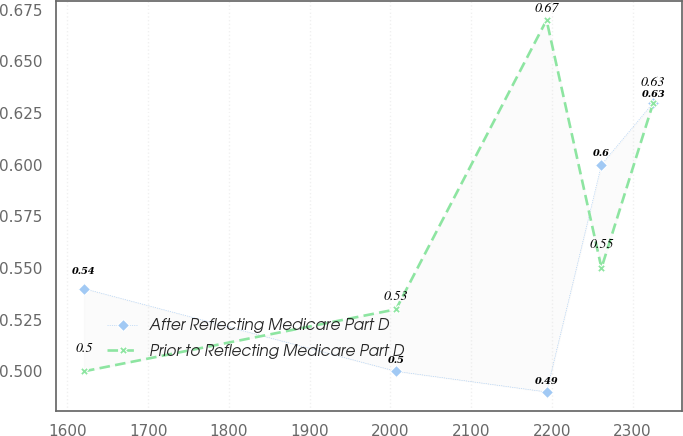Convert chart to OTSL. <chart><loc_0><loc_0><loc_500><loc_500><line_chart><ecel><fcel>After Reflecting Medicare Part D<fcel>Prior to Reflecting Medicare Part D<nl><fcel>1620.48<fcel>0.54<fcel>0.5<nl><fcel>2006.93<fcel>0.5<fcel>0.53<nl><fcel>2193.36<fcel>0.49<fcel>0.67<nl><fcel>2261.37<fcel>0.6<fcel>0.55<nl><fcel>2325.53<fcel>0.63<fcel>0.63<nl></chart> 